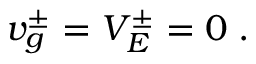<formula> <loc_0><loc_0><loc_500><loc_500>\begin{array} { r } { v _ { g } ^ { \pm } = V _ { E } ^ { \pm } = 0 \, . } \end{array}</formula> 